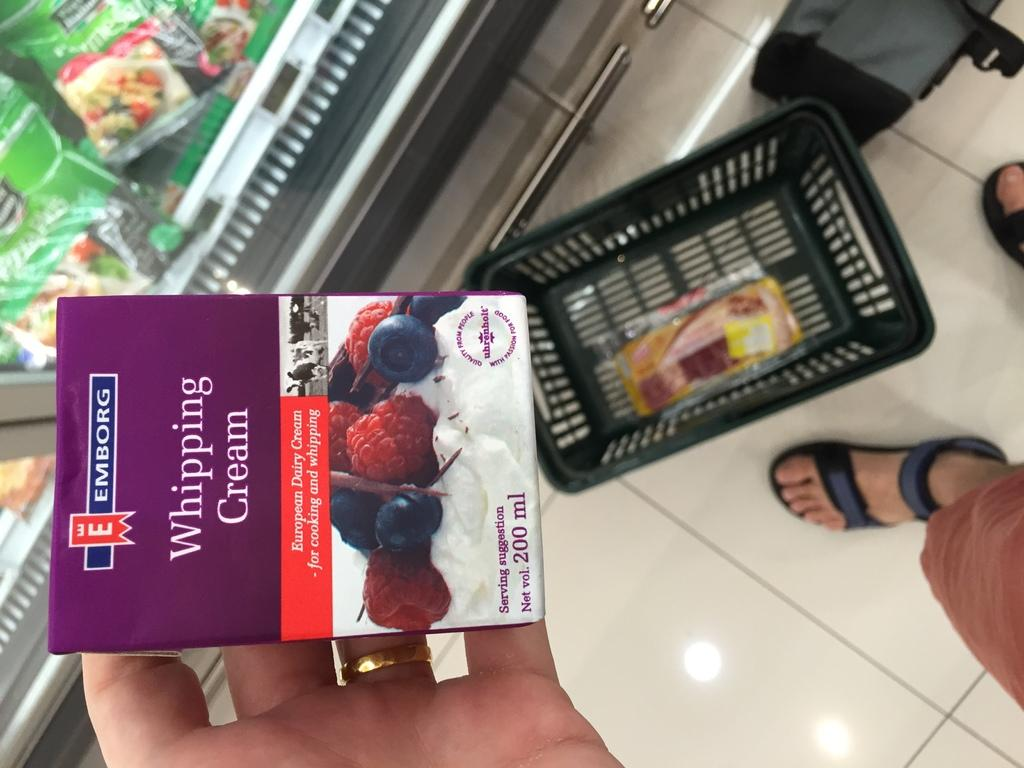<image>
Relay a brief, clear account of the picture shown. A box of Emborg Whipping cream taken in a super market 